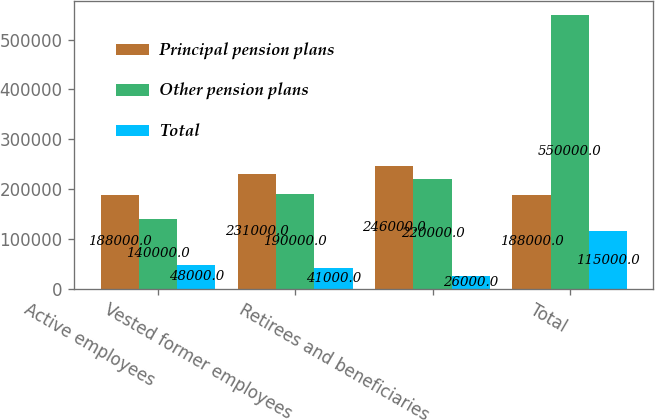Convert chart to OTSL. <chart><loc_0><loc_0><loc_500><loc_500><stacked_bar_chart><ecel><fcel>Active employees<fcel>Vested former employees<fcel>Retirees and beneficiaries<fcel>Total<nl><fcel>Principal pension plans<fcel>188000<fcel>231000<fcel>246000<fcel>188000<nl><fcel>Other pension plans<fcel>140000<fcel>190000<fcel>220000<fcel>550000<nl><fcel>Total<fcel>48000<fcel>41000<fcel>26000<fcel>115000<nl></chart> 